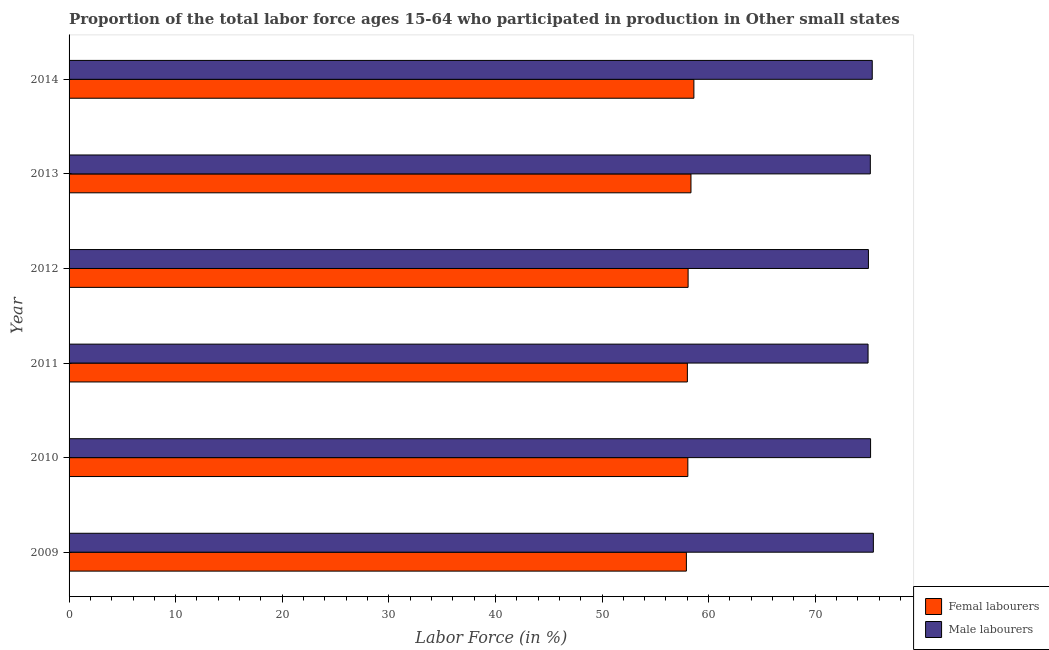How many different coloured bars are there?
Ensure brevity in your answer.  2. How many bars are there on the 5th tick from the top?
Offer a terse response. 2. What is the label of the 3rd group of bars from the top?
Offer a terse response. 2012. In how many cases, is the number of bars for a given year not equal to the number of legend labels?
Your answer should be very brief. 0. What is the percentage of male labour force in 2013?
Provide a succinct answer. 75.17. Across all years, what is the maximum percentage of female labor force?
Offer a terse response. 58.62. Across all years, what is the minimum percentage of female labor force?
Make the answer very short. 57.92. What is the total percentage of female labor force in the graph?
Your response must be concise. 349.02. What is the difference between the percentage of male labour force in 2010 and that in 2013?
Offer a very short reply. 0.02. What is the difference between the percentage of female labor force in 2011 and the percentage of male labour force in 2010?
Provide a succinct answer. -17.19. What is the average percentage of male labour force per year?
Offer a terse response. 75.19. In the year 2011, what is the difference between the percentage of female labor force and percentage of male labour force?
Provide a succinct answer. -16.95. In how many years, is the percentage of male labour force greater than 74 %?
Provide a short and direct response. 6. Is the percentage of male labour force in 2012 less than that in 2014?
Provide a succinct answer. Yes. What is the difference between the highest and the second highest percentage of male labour force?
Your answer should be very brief. 0.1. What does the 1st bar from the top in 2013 represents?
Keep it short and to the point. Male labourers. What does the 1st bar from the bottom in 2014 represents?
Provide a succinct answer. Femal labourers. How many bars are there?
Your response must be concise. 12. Are all the bars in the graph horizontal?
Your answer should be compact. Yes. How many years are there in the graph?
Offer a very short reply. 6. Where does the legend appear in the graph?
Your answer should be very brief. Bottom right. How many legend labels are there?
Your response must be concise. 2. How are the legend labels stacked?
Provide a succinct answer. Vertical. What is the title of the graph?
Ensure brevity in your answer.  Proportion of the total labor force ages 15-64 who participated in production in Other small states. Does "Unregistered firms" appear as one of the legend labels in the graph?
Ensure brevity in your answer.  No. What is the label or title of the X-axis?
Provide a succinct answer. Labor Force (in %). What is the Labor Force (in %) of Femal labourers in 2009?
Your answer should be compact. 57.92. What is the Labor Force (in %) of Male labourers in 2009?
Your answer should be very brief. 75.46. What is the Labor Force (in %) of Femal labourers in 2010?
Make the answer very short. 58.05. What is the Labor Force (in %) in Male labourers in 2010?
Your response must be concise. 75.2. What is the Labor Force (in %) of Femal labourers in 2011?
Keep it short and to the point. 58.01. What is the Labor Force (in %) in Male labourers in 2011?
Give a very brief answer. 74.96. What is the Labor Force (in %) of Femal labourers in 2012?
Keep it short and to the point. 58.08. What is the Labor Force (in %) in Male labourers in 2012?
Your answer should be compact. 74.99. What is the Labor Force (in %) in Femal labourers in 2013?
Provide a short and direct response. 58.35. What is the Labor Force (in %) in Male labourers in 2013?
Provide a succinct answer. 75.17. What is the Labor Force (in %) of Femal labourers in 2014?
Provide a short and direct response. 58.62. What is the Labor Force (in %) of Male labourers in 2014?
Provide a short and direct response. 75.35. Across all years, what is the maximum Labor Force (in %) of Femal labourers?
Offer a very short reply. 58.62. Across all years, what is the maximum Labor Force (in %) of Male labourers?
Give a very brief answer. 75.46. Across all years, what is the minimum Labor Force (in %) of Femal labourers?
Make the answer very short. 57.92. Across all years, what is the minimum Labor Force (in %) in Male labourers?
Offer a terse response. 74.96. What is the total Labor Force (in %) of Femal labourers in the graph?
Provide a succinct answer. 349.02. What is the total Labor Force (in %) of Male labourers in the graph?
Your answer should be very brief. 451.13. What is the difference between the Labor Force (in %) in Femal labourers in 2009 and that in 2010?
Your response must be concise. -0.14. What is the difference between the Labor Force (in %) of Male labourers in 2009 and that in 2010?
Your response must be concise. 0.26. What is the difference between the Labor Force (in %) in Femal labourers in 2009 and that in 2011?
Offer a terse response. -0.09. What is the difference between the Labor Force (in %) of Male labourers in 2009 and that in 2011?
Offer a very short reply. 0.5. What is the difference between the Labor Force (in %) in Femal labourers in 2009 and that in 2012?
Give a very brief answer. -0.16. What is the difference between the Labor Force (in %) in Male labourers in 2009 and that in 2012?
Your response must be concise. 0.46. What is the difference between the Labor Force (in %) in Femal labourers in 2009 and that in 2013?
Provide a short and direct response. -0.43. What is the difference between the Labor Force (in %) of Male labourers in 2009 and that in 2013?
Your response must be concise. 0.28. What is the difference between the Labor Force (in %) of Femal labourers in 2009 and that in 2014?
Ensure brevity in your answer.  -0.7. What is the difference between the Labor Force (in %) of Male labourers in 2009 and that in 2014?
Give a very brief answer. 0.1. What is the difference between the Labor Force (in %) of Femal labourers in 2010 and that in 2011?
Make the answer very short. 0.04. What is the difference between the Labor Force (in %) of Male labourers in 2010 and that in 2011?
Keep it short and to the point. 0.24. What is the difference between the Labor Force (in %) in Femal labourers in 2010 and that in 2012?
Your answer should be very brief. -0.02. What is the difference between the Labor Force (in %) in Male labourers in 2010 and that in 2012?
Keep it short and to the point. 0.2. What is the difference between the Labor Force (in %) in Femal labourers in 2010 and that in 2013?
Ensure brevity in your answer.  -0.29. What is the difference between the Labor Force (in %) in Male labourers in 2010 and that in 2013?
Make the answer very short. 0.02. What is the difference between the Labor Force (in %) of Femal labourers in 2010 and that in 2014?
Offer a terse response. -0.57. What is the difference between the Labor Force (in %) in Male labourers in 2010 and that in 2014?
Offer a terse response. -0.16. What is the difference between the Labor Force (in %) in Femal labourers in 2011 and that in 2012?
Ensure brevity in your answer.  -0.07. What is the difference between the Labor Force (in %) of Male labourers in 2011 and that in 2012?
Your answer should be very brief. -0.03. What is the difference between the Labor Force (in %) in Femal labourers in 2011 and that in 2013?
Offer a very short reply. -0.34. What is the difference between the Labor Force (in %) of Male labourers in 2011 and that in 2013?
Provide a short and direct response. -0.21. What is the difference between the Labor Force (in %) of Femal labourers in 2011 and that in 2014?
Your answer should be very brief. -0.61. What is the difference between the Labor Force (in %) in Male labourers in 2011 and that in 2014?
Your answer should be compact. -0.39. What is the difference between the Labor Force (in %) of Femal labourers in 2012 and that in 2013?
Offer a terse response. -0.27. What is the difference between the Labor Force (in %) in Male labourers in 2012 and that in 2013?
Provide a succinct answer. -0.18. What is the difference between the Labor Force (in %) of Femal labourers in 2012 and that in 2014?
Make the answer very short. -0.54. What is the difference between the Labor Force (in %) in Male labourers in 2012 and that in 2014?
Your response must be concise. -0.36. What is the difference between the Labor Force (in %) of Femal labourers in 2013 and that in 2014?
Give a very brief answer. -0.27. What is the difference between the Labor Force (in %) in Male labourers in 2013 and that in 2014?
Your answer should be very brief. -0.18. What is the difference between the Labor Force (in %) in Femal labourers in 2009 and the Labor Force (in %) in Male labourers in 2010?
Offer a very short reply. -17.28. What is the difference between the Labor Force (in %) of Femal labourers in 2009 and the Labor Force (in %) of Male labourers in 2011?
Ensure brevity in your answer.  -17.04. What is the difference between the Labor Force (in %) of Femal labourers in 2009 and the Labor Force (in %) of Male labourers in 2012?
Your answer should be very brief. -17.08. What is the difference between the Labor Force (in %) in Femal labourers in 2009 and the Labor Force (in %) in Male labourers in 2013?
Keep it short and to the point. -17.26. What is the difference between the Labor Force (in %) in Femal labourers in 2009 and the Labor Force (in %) in Male labourers in 2014?
Give a very brief answer. -17.44. What is the difference between the Labor Force (in %) of Femal labourers in 2010 and the Labor Force (in %) of Male labourers in 2011?
Your response must be concise. -16.91. What is the difference between the Labor Force (in %) of Femal labourers in 2010 and the Labor Force (in %) of Male labourers in 2012?
Ensure brevity in your answer.  -16.94. What is the difference between the Labor Force (in %) of Femal labourers in 2010 and the Labor Force (in %) of Male labourers in 2013?
Your answer should be very brief. -17.12. What is the difference between the Labor Force (in %) in Femal labourers in 2010 and the Labor Force (in %) in Male labourers in 2014?
Your response must be concise. -17.3. What is the difference between the Labor Force (in %) in Femal labourers in 2011 and the Labor Force (in %) in Male labourers in 2012?
Offer a very short reply. -16.98. What is the difference between the Labor Force (in %) in Femal labourers in 2011 and the Labor Force (in %) in Male labourers in 2013?
Your answer should be very brief. -17.16. What is the difference between the Labor Force (in %) of Femal labourers in 2011 and the Labor Force (in %) of Male labourers in 2014?
Ensure brevity in your answer.  -17.34. What is the difference between the Labor Force (in %) in Femal labourers in 2012 and the Labor Force (in %) in Male labourers in 2013?
Ensure brevity in your answer.  -17.1. What is the difference between the Labor Force (in %) in Femal labourers in 2012 and the Labor Force (in %) in Male labourers in 2014?
Give a very brief answer. -17.28. What is the difference between the Labor Force (in %) of Femal labourers in 2013 and the Labor Force (in %) of Male labourers in 2014?
Provide a short and direct response. -17.01. What is the average Labor Force (in %) of Femal labourers per year?
Provide a short and direct response. 58.17. What is the average Labor Force (in %) of Male labourers per year?
Your answer should be very brief. 75.19. In the year 2009, what is the difference between the Labor Force (in %) of Femal labourers and Labor Force (in %) of Male labourers?
Provide a short and direct response. -17.54. In the year 2010, what is the difference between the Labor Force (in %) in Femal labourers and Labor Force (in %) in Male labourers?
Your response must be concise. -17.14. In the year 2011, what is the difference between the Labor Force (in %) of Femal labourers and Labor Force (in %) of Male labourers?
Ensure brevity in your answer.  -16.95. In the year 2012, what is the difference between the Labor Force (in %) of Femal labourers and Labor Force (in %) of Male labourers?
Your answer should be compact. -16.92. In the year 2013, what is the difference between the Labor Force (in %) of Femal labourers and Labor Force (in %) of Male labourers?
Offer a terse response. -16.83. In the year 2014, what is the difference between the Labor Force (in %) in Femal labourers and Labor Force (in %) in Male labourers?
Provide a succinct answer. -16.73. What is the ratio of the Labor Force (in %) in Femal labourers in 2009 to that in 2010?
Your answer should be compact. 1. What is the ratio of the Labor Force (in %) in Male labourers in 2009 to that in 2011?
Keep it short and to the point. 1.01. What is the ratio of the Labor Force (in %) in Femal labourers in 2009 to that in 2012?
Your response must be concise. 1. What is the ratio of the Labor Force (in %) in Male labourers in 2009 to that in 2013?
Offer a terse response. 1. What is the ratio of the Labor Force (in %) in Male labourers in 2009 to that in 2014?
Ensure brevity in your answer.  1. What is the ratio of the Labor Force (in %) of Femal labourers in 2010 to that in 2011?
Ensure brevity in your answer.  1. What is the ratio of the Labor Force (in %) of Male labourers in 2010 to that in 2012?
Your response must be concise. 1. What is the ratio of the Labor Force (in %) in Femal labourers in 2010 to that in 2013?
Your answer should be very brief. 0.99. What is the ratio of the Labor Force (in %) in Male labourers in 2010 to that in 2013?
Ensure brevity in your answer.  1. What is the ratio of the Labor Force (in %) in Femal labourers in 2010 to that in 2014?
Offer a very short reply. 0.99. What is the ratio of the Labor Force (in %) of Male labourers in 2010 to that in 2014?
Your answer should be very brief. 1. What is the ratio of the Labor Force (in %) of Femal labourers in 2011 to that in 2012?
Give a very brief answer. 1. What is the ratio of the Labor Force (in %) of Male labourers in 2011 to that in 2012?
Offer a very short reply. 1. What is the ratio of the Labor Force (in %) in Male labourers in 2011 to that in 2013?
Offer a terse response. 1. What is the ratio of the Labor Force (in %) of Femal labourers in 2011 to that in 2014?
Provide a short and direct response. 0.99. What is the ratio of the Labor Force (in %) in Male labourers in 2013 to that in 2014?
Your response must be concise. 1. What is the difference between the highest and the second highest Labor Force (in %) in Femal labourers?
Provide a short and direct response. 0.27. What is the difference between the highest and the second highest Labor Force (in %) in Male labourers?
Your answer should be compact. 0.1. What is the difference between the highest and the lowest Labor Force (in %) of Femal labourers?
Give a very brief answer. 0.7. What is the difference between the highest and the lowest Labor Force (in %) of Male labourers?
Ensure brevity in your answer.  0.5. 